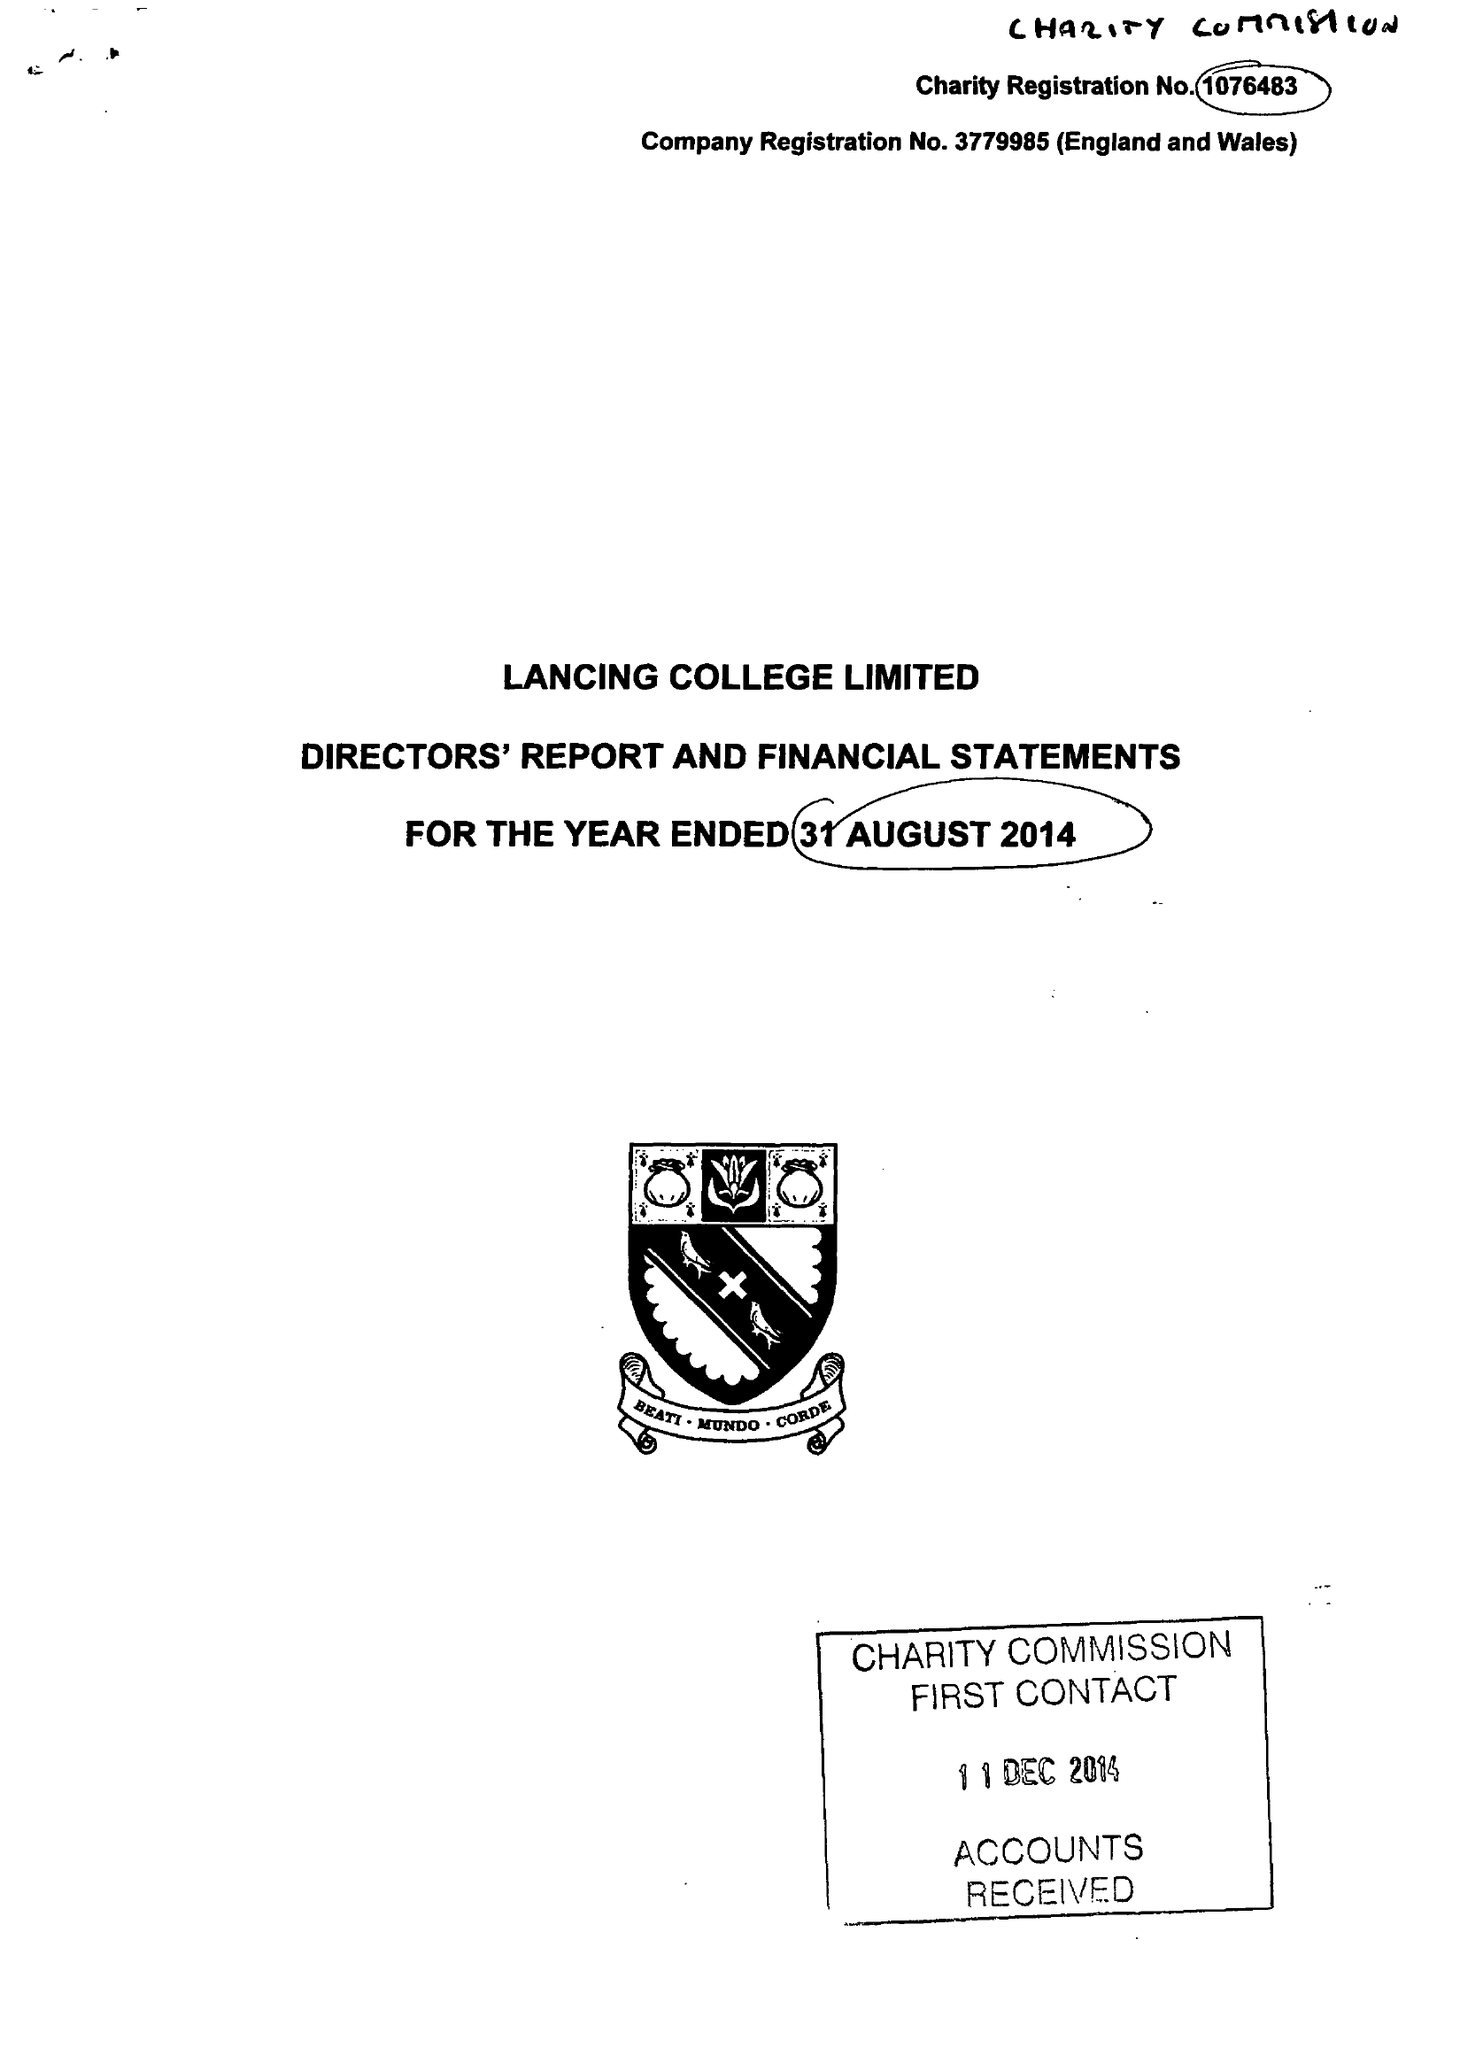What is the value for the charity_name?
Answer the question using a single word or phrase. Lancing College Ltd. 